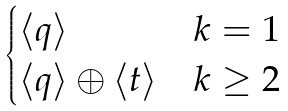<formula> <loc_0><loc_0><loc_500><loc_500>\begin{cases} \langle q \rangle & k = 1 \\ \langle q \rangle \oplus \langle t \rangle & k \geq 2 \end{cases}</formula> 